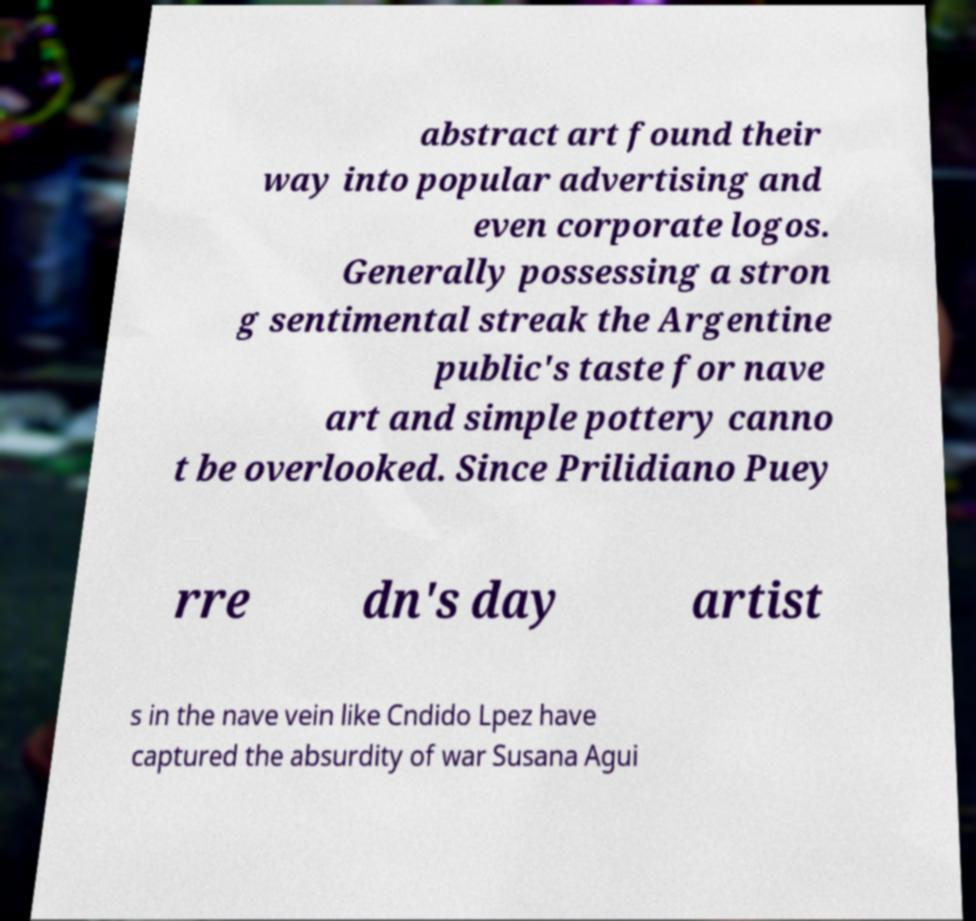What messages or text are displayed in this image? I need them in a readable, typed format. abstract art found their way into popular advertising and even corporate logos. Generally possessing a stron g sentimental streak the Argentine public's taste for nave art and simple pottery canno t be overlooked. Since Prilidiano Puey rre dn's day artist s in the nave vein like Cndido Lpez have captured the absurdity of war Susana Agui 